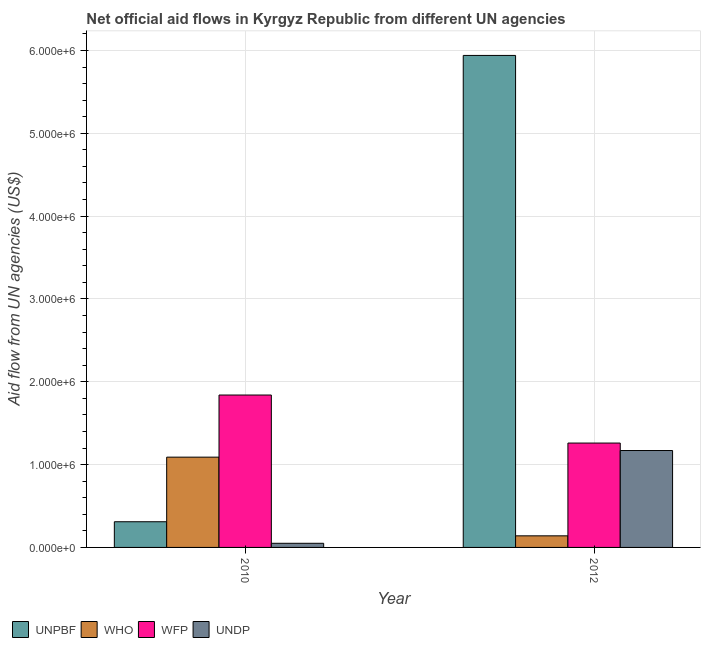How many different coloured bars are there?
Provide a short and direct response. 4. How many bars are there on the 2nd tick from the right?
Offer a terse response. 4. What is the label of the 2nd group of bars from the left?
Your answer should be compact. 2012. In how many cases, is the number of bars for a given year not equal to the number of legend labels?
Your answer should be compact. 0. What is the amount of aid given by undp in 2010?
Offer a very short reply. 5.00e+04. Across all years, what is the maximum amount of aid given by who?
Your answer should be compact. 1.09e+06. Across all years, what is the minimum amount of aid given by unpbf?
Provide a succinct answer. 3.10e+05. What is the total amount of aid given by undp in the graph?
Keep it short and to the point. 1.22e+06. What is the difference between the amount of aid given by undp in 2010 and that in 2012?
Your response must be concise. -1.12e+06. What is the difference between the amount of aid given by who in 2012 and the amount of aid given by unpbf in 2010?
Provide a succinct answer. -9.50e+05. What is the average amount of aid given by who per year?
Offer a very short reply. 6.15e+05. In the year 2010, what is the difference between the amount of aid given by who and amount of aid given by unpbf?
Offer a very short reply. 0. In how many years, is the amount of aid given by undp greater than 5400000 US$?
Your response must be concise. 0. What is the ratio of the amount of aid given by undp in 2010 to that in 2012?
Provide a succinct answer. 0.04. Is the amount of aid given by undp in 2010 less than that in 2012?
Your answer should be very brief. Yes. What does the 3rd bar from the left in 2010 represents?
Keep it short and to the point. WFP. What does the 3rd bar from the right in 2012 represents?
Your answer should be very brief. WHO. Is it the case that in every year, the sum of the amount of aid given by unpbf and amount of aid given by who is greater than the amount of aid given by wfp?
Offer a very short reply. No. How many bars are there?
Offer a terse response. 8. Are all the bars in the graph horizontal?
Your answer should be very brief. No. How many years are there in the graph?
Provide a short and direct response. 2. Does the graph contain any zero values?
Keep it short and to the point. No. Does the graph contain grids?
Your response must be concise. Yes. Where does the legend appear in the graph?
Make the answer very short. Bottom left. How many legend labels are there?
Your answer should be compact. 4. How are the legend labels stacked?
Give a very brief answer. Horizontal. What is the title of the graph?
Provide a succinct answer. Net official aid flows in Kyrgyz Republic from different UN agencies. Does "Methodology assessment" appear as one of the legend labels in the graph?
Ensure brevity in your answer.  No. What is the label or title of the Y-axis?
Make the answer very short. Aid flow from UN agencies (US$). What is the Aid flow from UN agencies (US$) in WHO in 2010?
Provide a short and direct response. 1.09e+06. What is the Aid flow from UN agencies (US$) in WFP in 2010?
Offer a very short reply. 1.84e+06. What is the Aid flow from UN agencies (US$) of UNDP in 2010?
Offer a terse response. 5.00e+04. What is the Aid flow from UN agencies (US$) of UNPBF in 2012?
Make the answer very short. 5.94e+06. What is the Aid flow from UN agencies (US$) in WFP in 2012?
Provide a succinct answer. 1.26e+06. What is the Aid flow from UN agencies (US$) in UNDP in 2012?
Make the answer very short. 1.17e+06. Across all years, what is the maximum Aid flow from UN agencies (US$) in UNPBF?
Provide a succinct answer. 5.94e+06. Across all years, what is the maximum Aid flow from UN agencies (US$) in WHO?
Keep it short and to the point. 1.09e+06. Across all years, what is the maximum Aid flow from UN agencies (US$) in WFP?
Keep it short and to the point. 1.84e+06. Across all years, what is the maximum Aid flow from UN agencies (US$) of UNDP?
Offer a terse response. 1.17e+06. Across all years, what is the minimum Aid flow from UN agencies (US$) of UNPBF?
Provide a succinct answer. 3.10e+05. Across all years, what is the minimum Aid flow from UN agencies (US$) of WFP?
Offer a terse response. 1.26e+06. What is the total Aid flow from UN agencies (US$) in UNPBF in the graph?
Provide a succinct answer. 6.25e+06. What is the total Aid flow from UN agencies (US$) of WHO in the graph?
Your response must be concise. 1.23e+06. What is the total Aid flow from UN agencies (US$) in WFP in the graph?
Your response must be concise. 3.10e+06. What is the total Aid flow from UN agencies (US$) of UNDP in the graph?
Your answer should be compact. 1.22e+06. What is the difference between the Aid flow from UN agencies (US$) in UNPBF in 2010 and that in 2012?
Make the answer very short. -5.63e+06. What is the difference between the Aid flow from UN agencies (US$) in WHO in 2010 and that in 2012?
Provide a short and direct response. 9.50e+05. What is the difference between the Aid flow from UN agencies (US$) in WFP in 2010 and that in 2012?
Provide a succinct answer. 5.80e+05. What is the difference between the Aid flow from UN agencies (US$) in UNDP in 2010 and that in 2012?
Keep it short and to the point. -1.12e+06. What is the difference between the Aid flow from UN agencies (US$) in UNPBF in 2010 and the Aid flow from UN agencies (US$) in WFP in 2012?
Make the answer very short. -9.50e+05. What is the difference between the Aid flow from UN agencies (US$) of UNPBF in 2010 and the Aid flow from UN agencies (US$) of UNDP in 2012?
Give a very brief answer. -8.60e+05. What is the difference between the Aid flow from UN agencies (US$) in WHO in 2010 and the Aid flow from UN agencies (US$) in UNDP in 2012?
Offer a very short reply. -8.00e+04. What is the difference between the Aid flow from UN agencies (US$) in WFP in 2010 and the Aid flow from UN agencies (US$) in UNDP in 2012?
Your response must be concise. 6.70e+05. What is the average Aid flow from UN agencies (US$) in UNPBF per year?
Your answer should be very brief. 3.12e+06. What is the average Aid flow from UN agencies (US$) of WHO per year?
Offer a very short reply. 6.15e+05. What is the average Aid flow from UN agencies (US$) in WFP per year?
Keep it short and to the point. 1.55e+06. In the year 2010, what is the difference between the Aid flow from UN agencies (US$) in UNPBF and Aid flow from UN agencies (US$) in WHO?
Provide a succinct answer. -7.80e+05. In the year 2010, what is the difference between the Aid flow from UN agencies (US$) in UNPBF and Aid flow from UN agencies (US$) in WFP?
Offer a terse response. -1.53e+06. In the year 2010, what is the difference between the Aid flow from UN agencies (US$) of UNPBF and Aid flow from UN agencies (US$) of UNDP?
Give a very brief answer. 2.60e+05. In the year 2010, what is the difference between the Aid flow from UN agencies (US$) of WHO and Aid flow from UN agencies (US$) of WFP?
Make the answer very short. -7.50e+05. In the year 2010, what is the difference between the Aid flow from UN agencies (US$) in WHO and Aid flow from UN agencies (US$) in UNDP?
Make the answer very short. 1.04e+06. In the year 2010, what is the difference between the Aid flow from UN agencies (US$) of WFP and Aid flow from UN agencies (US$) of UNDP?
Provide a short and direct response. 1.79e+06. In the year 2012, what is the difference between the Aid flow from UN agencies (US$) of UNPBF and Aid flow from UN agencies (US$) of WHO?
Keep it short and to the point. 5.80e+06. In the year 2012, what is the difference between the Aid flow from UN agencies (US$) in UNPBF and Aid flow from UN agencies (US$) in WFP?
Offer a very short reply. 4.68e+06. In the year 2012, what is the difference between the Aid flow from UN agencies (US$) of UNPBF and Aid flow from UN agencies (US$) of UNDP?
Offer a very short reply. 4.77e+06. In the year 2012, what is the difference between the Aid flow from UN agencies (US$) of WHO and Aid flow from UN agencies (US$) of WFP?
Make the answer very short. -1.12e+06. In the year 2012, what is the difference between the Aid flow from UN agencies (US$) in WHO and Aid flow from UN agencies (US$) in UNDP?
Offer a very short reply. -1.03e+06. What is the ratio of the Aid flow from UN agencies (US$) of UNPBF in 2010 to that in 2012?
Your answer should be compact. 0.05. What is the ratio of the Aid flow from UN agencies (US$) in WHO in 2010 to that in 2012?
Provide a succinct answer. 7.79. What is the ratio of the Aid flow from UN agencies (US$) of WFP in 2010 to that in 2012?
Offer a terse response. 1.46. What is the ratio of the Aid flow from UN agencies (US$) of UNDP in 2010 to that in 2012?
Provide a short and direct response. 0.04. What is the difference between the highest and the second highest Aid flow from UN agencies (US$) of UNPBF?
Provide a short and direct response. 5.63e+06. What is the difference between the highest and the second highest Aid flow from UN agencies (US$) in WHO?
Make the answer very short. 9.50e+05. What is the difference between the highest and the second highest Aid flow from UN agencies (US$) of WFP?
Your response must be concise. 5.80e+05. What is the difference between the highest and the second highest Aid flow from UN agencies (US$) in UNDP?
Provide a succinct answer. 1.12e+06. What is the difference between the highest and the lowest Aid flow from UN agencies (US$) of UNPBF?
Offer a terse response. 5.63e+06. What is the difference between the highest and the lowest Aid flow from UN agencies (US$) in WHO?
Provide a short and direct response. 9.50e+05. What is the difference between the highest and the lowest Aid flow from UN agencies (US$) of WFP?
Ensure brevity in your answer.  5.80e+05. What is the difference between the highest and the lowest Aid flow from UN agencies (US$) in UNDP?
Provide a succinct answer. 1.12e+06. 